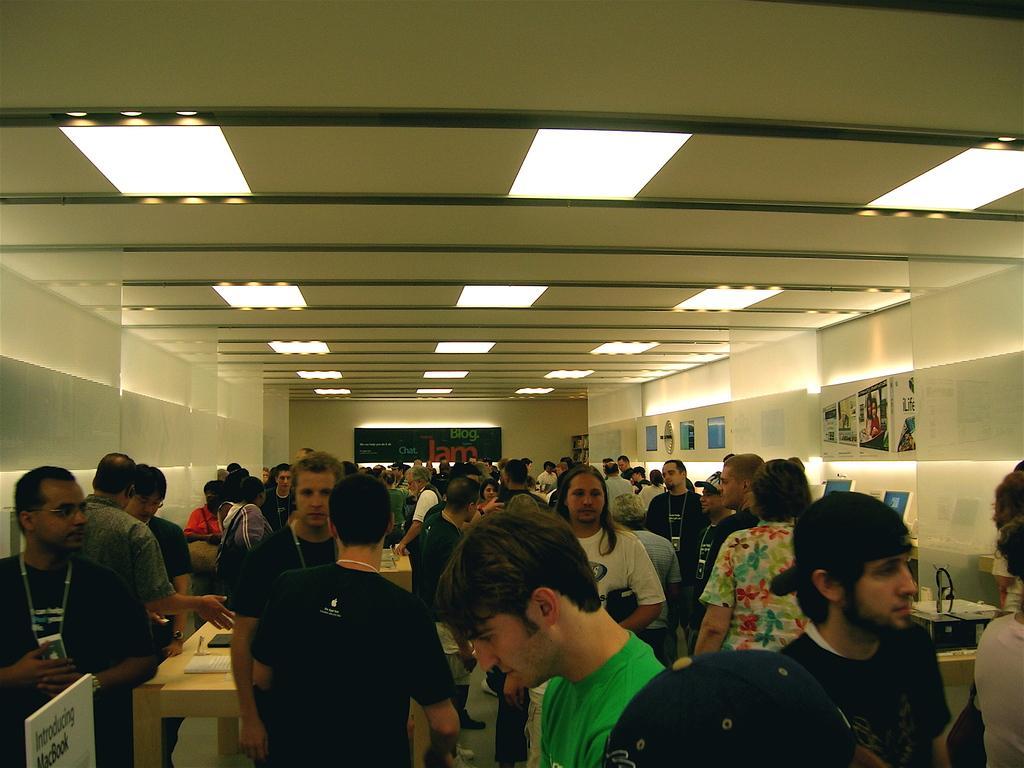In one or two sentences, can you explain what this image depicts? In this image I can see the group of people standing. And these people are wearing the different color dresses. In-between these people I can see the table and some papers on it. To the left I can see the board and something written on it. In the back there is a board to the wall. To the right I can see some papers to the wall. In the top I can see the lights and ceiling. 